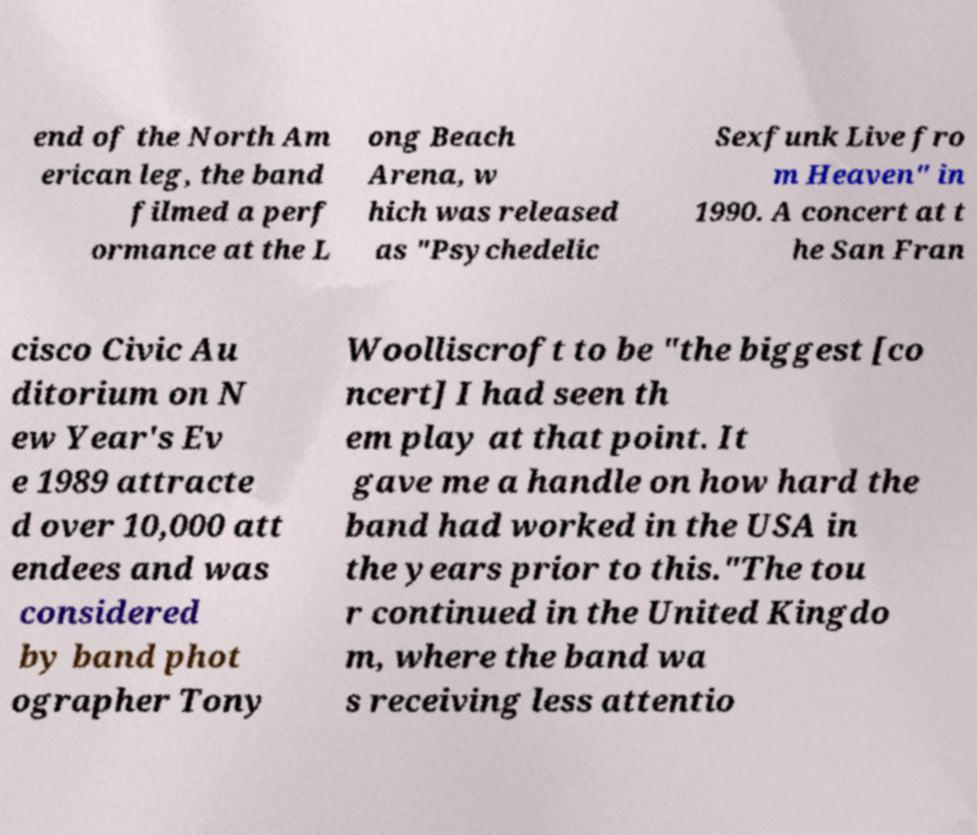For documentation purposes, I need the text within this image transcribed. Could you provide that? end of the North Am erican leg, the band filmed a perf ormance at the L ong Beach Arena, w hich was released as "Psychedelic Sexfunk Live fro m Heaven" in 1990. A concert at t he San Fran cisco Civic Au ditorium on N ew Year's Ev e 1989 attracte d over 10,000 att endees and was considered by band phot ographer Tony Woolliscroft to be "the biggest [co ncert] I had seen th em play at that point. It gave me a handle on how hard the band had worked in the USA in the years prior to this."The tou r continued in the United Kingdo m, where the band wa s receiving less attentio 